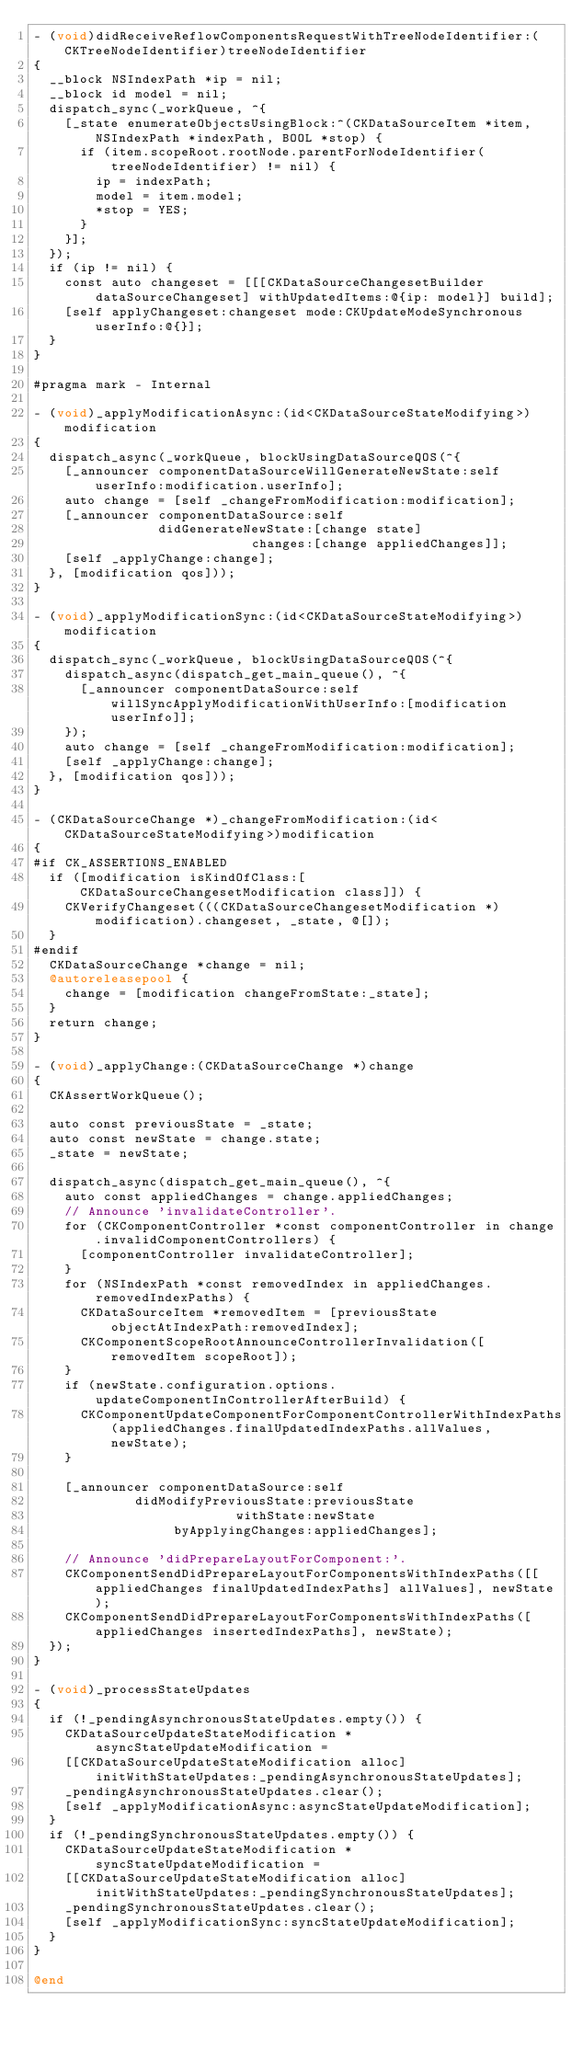Convert code to text. <code><loc_0><loc_0><loc_500><loc_500><_ObjectiveC_>- (void)didReceiveReflowComponentsRequestWithTreeNodeIdentifier:(CKTreeNodeIdentifier)treeNodeIdentifier
{
  __block NSIndexPath *ip = nil;
  __block id model = nil;
  dispatch_sync(_workQueue, ^{
    [_state enumerateObjectsUsingBlock:^(CKDataSourceItem *item, NSIndexPath *indexPath, BOOL *stop) {
      if (item.scopeRoot.rootNode.parentForNodeIdentifier(treeNodeIdentifier) != nil) {
        ip = indexPath;
        model = item.model;
        *stop = YES;
      }
    }];
  });
  if (ip != nil) {
    const auto changeset = [[[CKDataSourceChangesetBuilder dataSourceChangeset] withUpdatedItems:@{ip: model}] build];
    [self applyChangeset:changeset mode:CKUpdateModeSynchronous userInfo:@{}];
  }
}

#pragma mark - Internal

- (void)_applyModificationAsync:(id<CKDataSourceStateModifying>)modification
{
  dispatch_async(_workQueue, blockUsingDataSourceQOS(^{
    [_announcer componentDataSourceWillGenerateNewState:self userInfo:modification.userInfo];
    auto change = [self _changeFromModification:modification];
    [_announcer componentDataSource:self
                didGenerateNewState:[change state]
                            changes:[change appliedChanges]];
    [self _applyChange:change];
  }, [modification qos]));
}

- (void)_applyModificationSync:(id<CKDataSourceStateModifying>)modification
{
  dispatch_sync(_workQueue, blockUsingDataSourceQOS(^{
    dispatch_async(dispatch_get_main_queue(), ^{
      [_announcer componentDataSource:self willSyncApplyModificationWithUserInfo:[modification userInfo]];
    });
    auto change = [self _changeFromModification:modification];
    [self _applyChange:change];
  }, [modification qos]));
}

- (CKDataSourceChange *)_changeFromModification:(id<CKDataSourceStateModifying>)modification
{
#if CK_ASSERTIONS_ENABLED
  if ([modification isKindOfClass:[CKDataSourceChangesetModification class]]) {
    CKVerifyChangeset(((CKDataSourceChangesetModification *)modification).changeset, _state, @[]);
  }
#endif
  CKDataSourceChange *change = nil;
  @autoreleasepool {
    change = [modification changeFromState:_state];
  }
  return change;
}

- (void)_applyChange:(CKDataSourceChange *)change
{
  CKAssertWorkQueue();
  
  auto const previousState = _state;
  auto const newState = change.state;
  _state = newState;

  dispatch_async(dispatch_get_main_queue(), ^{
    auto const appliedChanges = change.appliedChanges;
    // Announce 'invalidateController'.
    for (CKComponentController *const componentController in change.invalidComponentControllers) {
      [componentController invalidateController];
    }
    for (NSIndexPath *const removedIndex in appliedChanges.removedIndexPaths) {
      CKDataSourceItem *removedItem = [previousState objectAtIndexPath:removedIndex];
      CKComponentScopeRootAnnounceControllerInvalidation([removedItem scopeRoot]);
    }
    if (newState.configuration.options.updateComponentInControllerAfterBuild) {
      CKComponentUpdateComponentForComponentControllerWithIndexPaths(appliedChanges.finalUpdatedIndexPaths.allValues, newState);
    }

    [_announcer componentDataSource:self
             didModifyPreviousState:previousState
                          withState:newState
                  byApplyingChanges:appliedChanges];

    // Announce 'didPrepareLayoutForComponent:'.
    CKComponentSendDidPrepareLayoutForComponentsWithIndexPaths([[appliedChanges finalUpdatedIndexPaths] allValues], newState);
    CKComponentSendDidPrepareLayoutForComponentsWithIndexPaths([appliedChanges insertedIndexPaths], newState);
  });
}

- (void)_processStateUpdates
{
  if (!_pendingAsynchronousStateUpdates.empty()) {
    CKDataSourceUpdateStateModification *asyncStateUpdateModification =
    [[CKDataSourceUpdateStateModification alloc] initWithStateUpdates:_pendingAsynchronousStateUpdates];
    _pendingAsynchronousStateUpdates.clear();
    [self _applyModificationAsync:asyncStateUpdateModification];
  }
  if (!_pendingSynchronousStateUpdates.empty()) {
    CKDataSourceUpdateStateModification *syncStateUpdateModification =
    [[CKDataSourceUpdateStateModification alloc] initWithStateUpdates:_pendingSynchronousStateUpdates];
    _pendingSynchronousStateUpdates.clear();
    [self _applyModificationSync:syncStateUpdateModification];
  }
}

@end
</code> 